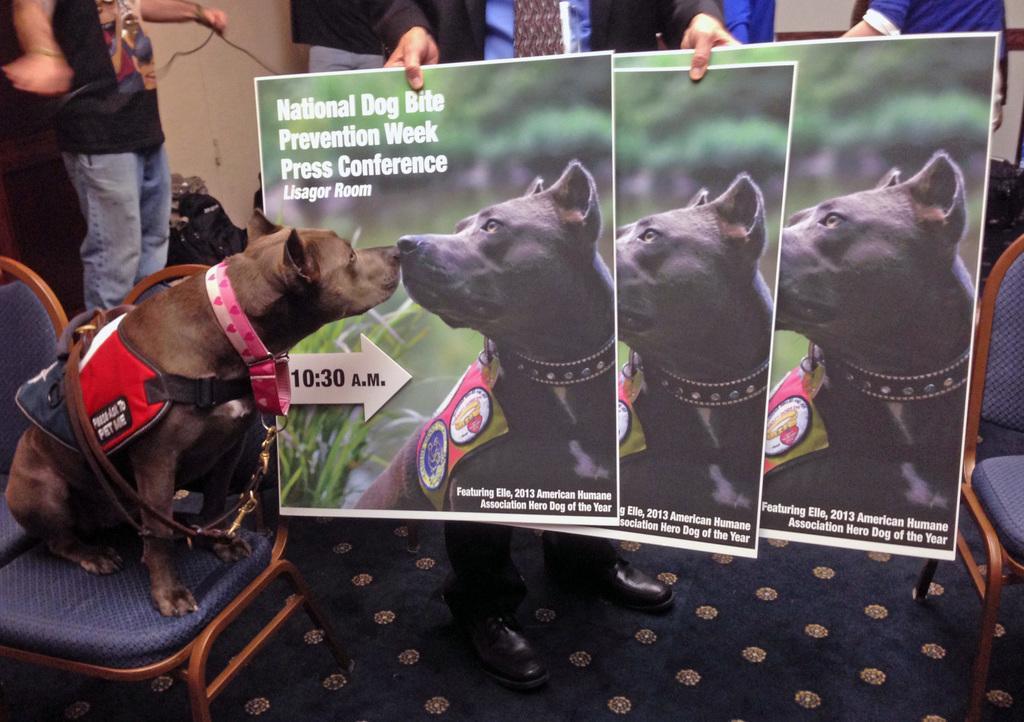Describe this image in one or two sentences. Here there are posters, this is dog on the chair, where people are standing. 